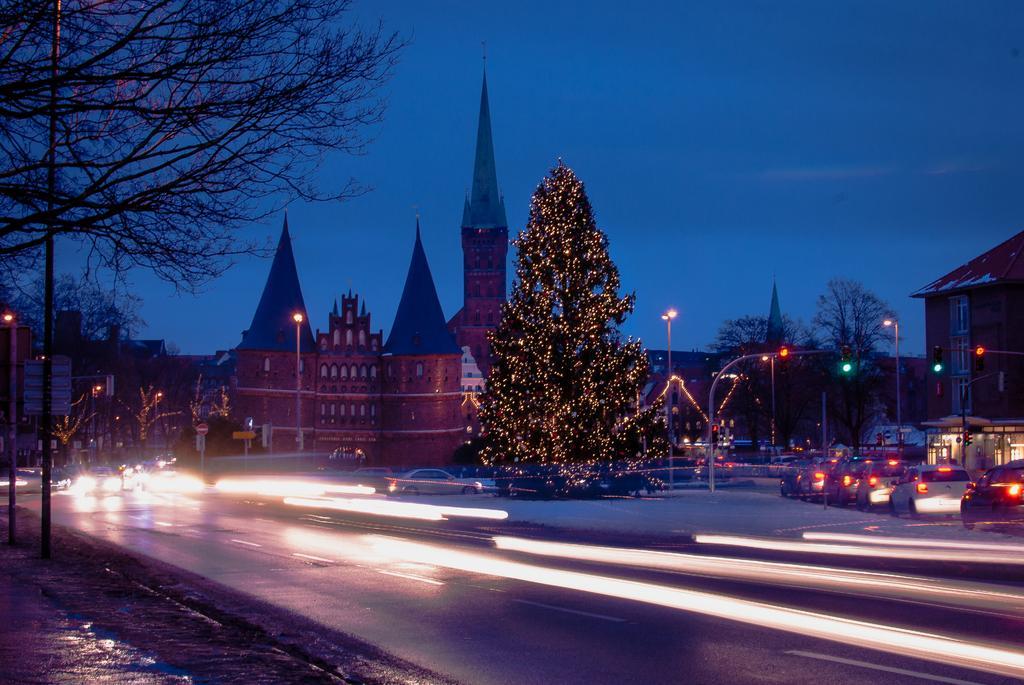Could you give a brief overview of what you see in this image? In this image w c and see decorated Christmas tree, buildings, street poles, street lights, motor vehicles on the road, trees and sky. 